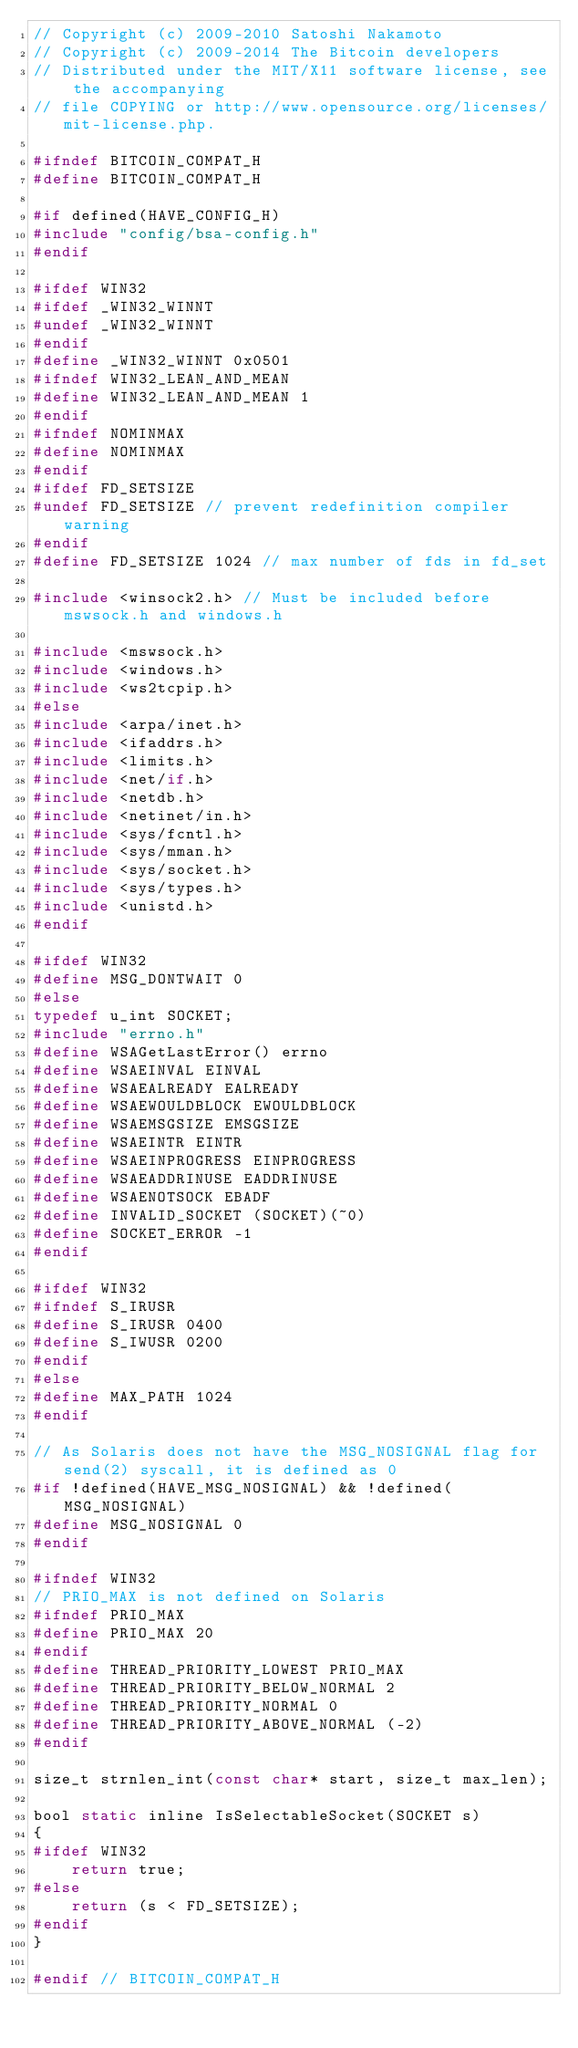Convert code to text. <code><loc_0><loc_0><loc_500><loc_500><_C_>// Copyright (c) 2009-2010 Satoshi Nakamoto
// Copyright (c) 2009-2014 The Bitcoin developers
// Distributed under the MIT/X11 software license, see the accompanying
// file COPYING or http://www.opensource.org/licenses/mit-license.php.

#ifndef BITCOIN_COMPAT_H
#define BITCOIN_COMPAT_H

#if defined(HAVE_CONFIG_H)
#include "config/bsa-config.h"
#endif

#ifdef WIN32
#ifdef _WIN32_WINNT
#undef _WIN32_WINNT
#endif
#define _WIN32_WINNT 0x0501
#ifndef WIN32_LEAN_AND_MEAN
#define WIN32_LEAN_AND_MEAN 1
#endif
#ifndef NOMINMAX
#define NOMINMAX
#endif
#ifdef FD_SETSIZE
#undef FD_SETSIZE // prevent redefinition compiler warning
#endif
#define FD_SETSIZE 1024 // max number of fds in fd_set

#include <winsock2.h> // Must be included before mswsock.h and windows.h

#include <mswsock.h>
#include <windows.h>
#include <ws2tcpip.h>
#else
#include <arpa/inet.h>
#include <ifaddrs.h>
#include <limits.h>
#include <net/if.h>
#include <netdb.h>
#include <netinet/in.h>
#include <sys/fcntl.h>
#include <sys/mman.h>
#include <sys/socket.h>
#include <sys/types.h>
#include <unistd.h>
#endif

#ifdef WIN32
#define MSG_DONTWAIT 0
#else
typedef u_int SOCKET;
#include "errno.h"
#define WSAGetLastError() errno
#define WSAEINVAL EINVAL
#define WSAEALREADY EALREADY
#define WSAEWOULDBLOCK EWOULDBLOCK
#define WSAEMSGSIZE EMSGSIZE
#define WSAEINTR EINTR
#define WSAEINPROGRESS EINPROGRESS
#define WSAEADDRINUSE EADDRINUSE
#define WSAENOTSOCK EBADF
#define INVALID_SOCKET (SOCKET)(~0)
#define SOCKET_ERROR -1
#endif

#ifdef WIN32
#ifndef S_IRUSR
#define S_IRUSR 0400
#define S_IWUSR 0200
#endif
#else
#define MAX_PATH 1024
#endif

// As Solaris does not have the MSG_NOSIGNAL flag for send(2) syscall, it is defined as 0
#if !defined(HAVE_MSG_NOSIGNAL) && !defined(MSG_NOSIGNAL)
#define MSG_NOSIGNAL 0
#endif

#ifndef WIN32
// PRIO_MAX is not defined on Solaris
#ifndef PRIO_MAX
#define PRIO_MAX 20
#endif
#define THREAD_PRIORITY_LOWEST PRIO_MAX
#define THREAD_PRIORITY_BELOW_NORMAL 2
#define THREAD_PRIORITY_NORMAL 0
#define THREAD_PRIORITY_ABOVE_NORMAL (-2)
#endif

size_t strnlen_int(const char* start, size_t max_len);

bool static inline IsSelectableSocket(SOCKET s)
{
#ifdef WIN32
    return true;
#else
    return (s < FD_SETSIZE);
#endif
}

#endif // BITCOIN_COMPAT_H
</code> 